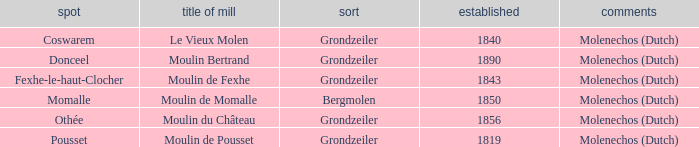What is year Built of the Moulin de Momalle Mill? 1850.0. 